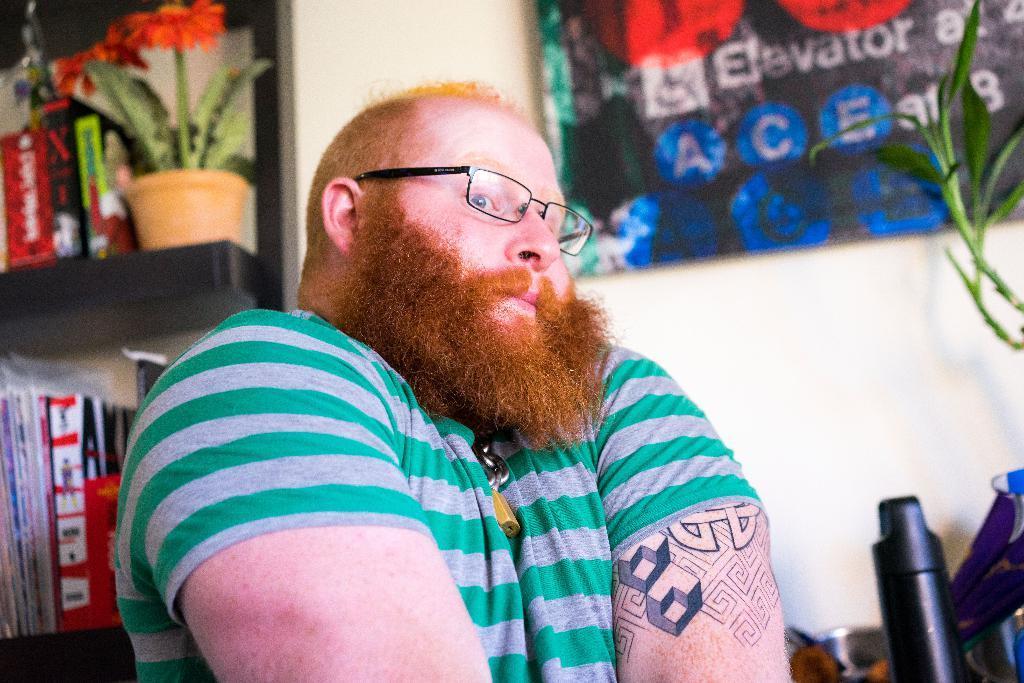Could you give a brief overview of what you see in this image? In this image I can see a man, I can see he is wearing green t-shirt and specs. In background I can see a plant, green leaves, a bottle and few stuffs on these shelves. I can also see something is written in background and I can see this image is little bit blurry from background. 